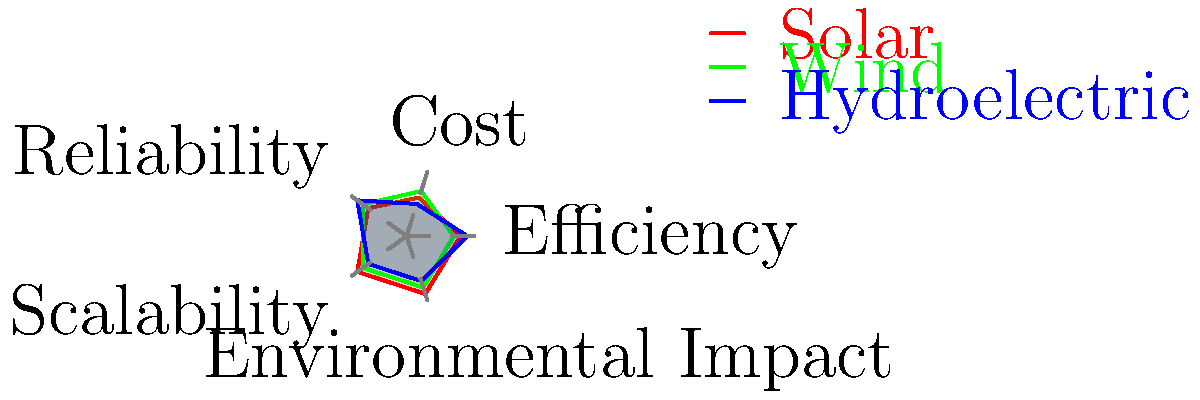Based on the radar chart comparing solar, wind, and hydroelectric energy sources, which renewable energy source would be most suitable for large-scale implementation in regions with limited water resources but abundant sunlight? To determine the most suitable renewable energy source for the given scenario, we need to analyze each aspect of the radar chart:

1. Efficiency:
   Solar: 0.8
   Wind: 0.7
   Hydroelectric: 0.9

2. Cost:
   Solar: 0.6
   Wind: 0.7
   Hydroelectric: 0.5

3. Reliability:
   Solar: 0.7
   Wind: 0.8
   Hydroelectric: 0.9

4. Scalability:
   Solar: 0.9
   Wind: 0.8
   Hydroelectric: 0.7

5. Environmental Impact:
   Solar: 0.9
   Wind: 0.8
   Hydroelectric: 0.7

Considering the scenario of "regions with limited water resources but abundant sunlight":

1. Hydroelectric energy is not suitable due to the limited water resources.
2. Solar energy has the highest scalability (0.9) and environmental impact (0.9) ratings.
3. Solar energy also has good efficiency (0.8) and moderate reliability (0.7).
4. While the cost of solar energy is slightly lower than wind (0.6 vs 0.7), it is offset by its higher scalability and efficiency.
5. The abundance of sunlight in the region further supports the choice of solar energy.

Therefore, solar energy would be the most suitable renewable energy source for large-scale implementation in this scenario.
Answer: Solar energy 